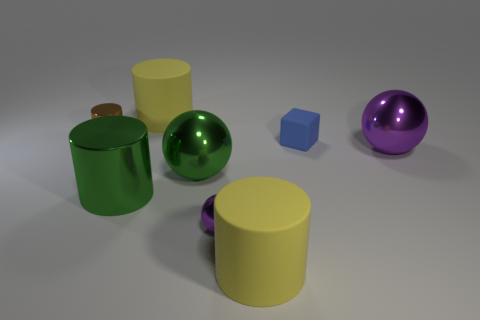Subtract all purple balls. How many were subtracted if there are1purple balls left? 1 Add 1 purple metal balls. How many objects exist? 9 Subtract all balls. How many objects are left? 5 Add 5 big green spheres. How many big green spheres exist? 6 Subtract 0 gray cubes. How many objects are left? 8 Subtract all small blue matte spheres. Subtract all small brown metallic cylinders. How many objects are left? 7 Add 8 big rubber objects. How many big rubber objects are left? 10 